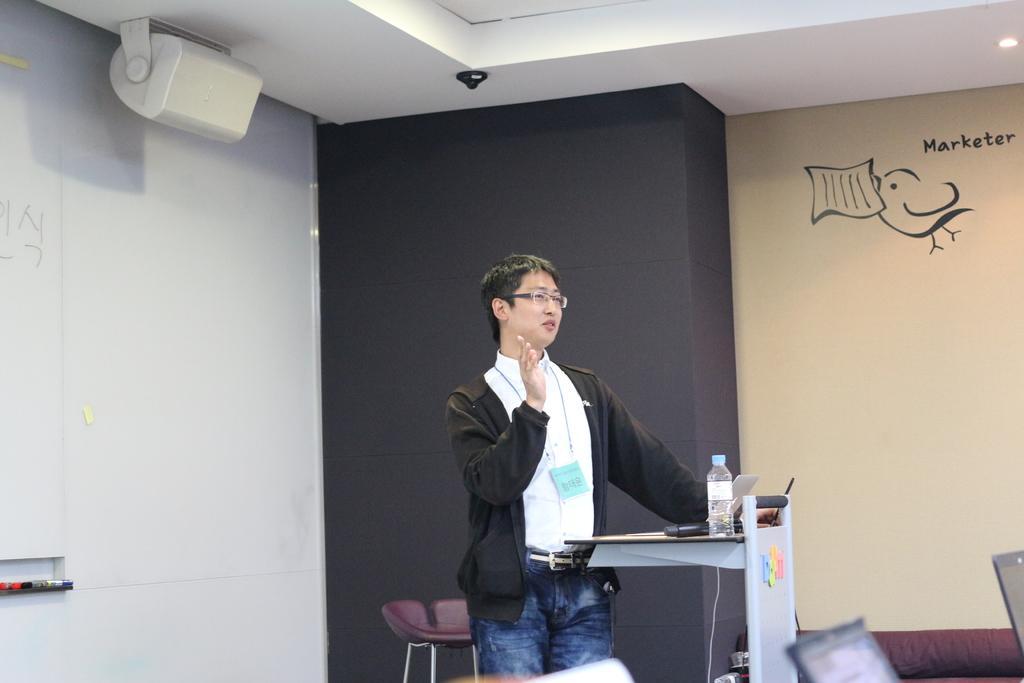Could you give a brief overview of what you see in this image? This picture is taken inside the room. In this image, in the middle, we can see a man standing in front of a table, on the table, we can see a laptop and a water bottle. In the right corner, we can see three laptops. In the background, we can see black color and a wall with some paintings. At the top, we can see some electronic objects and a roof. 